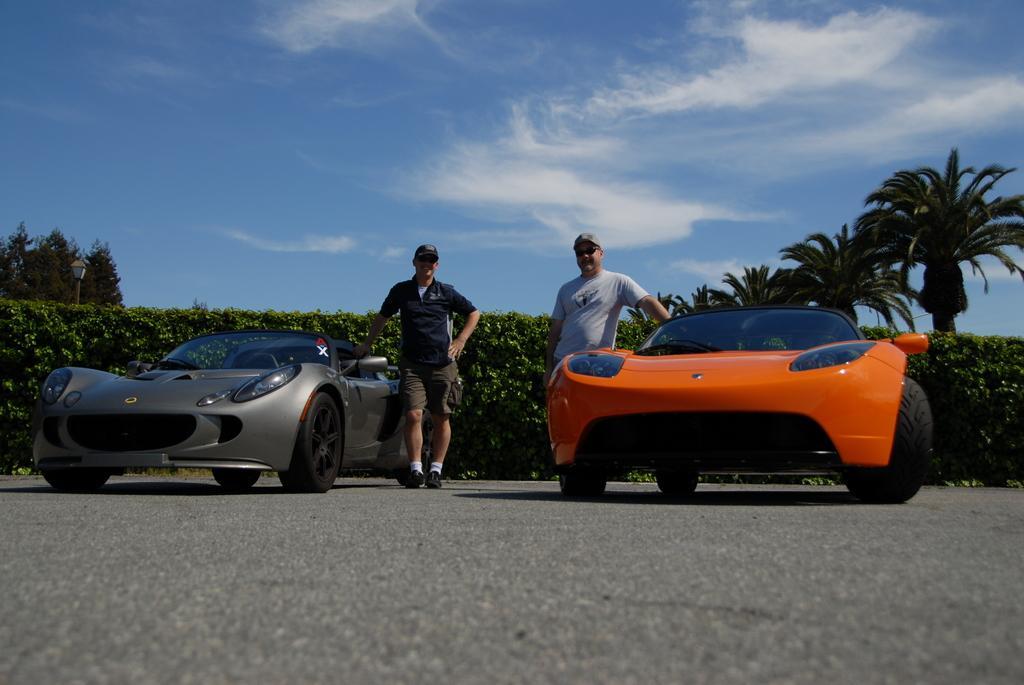In one or two sentences, can you explain what this image depicts? In this image there are cars on the road and we can see two people standing. In the background there are trees and sky and we can see a hedge. On the left there is a pole. 